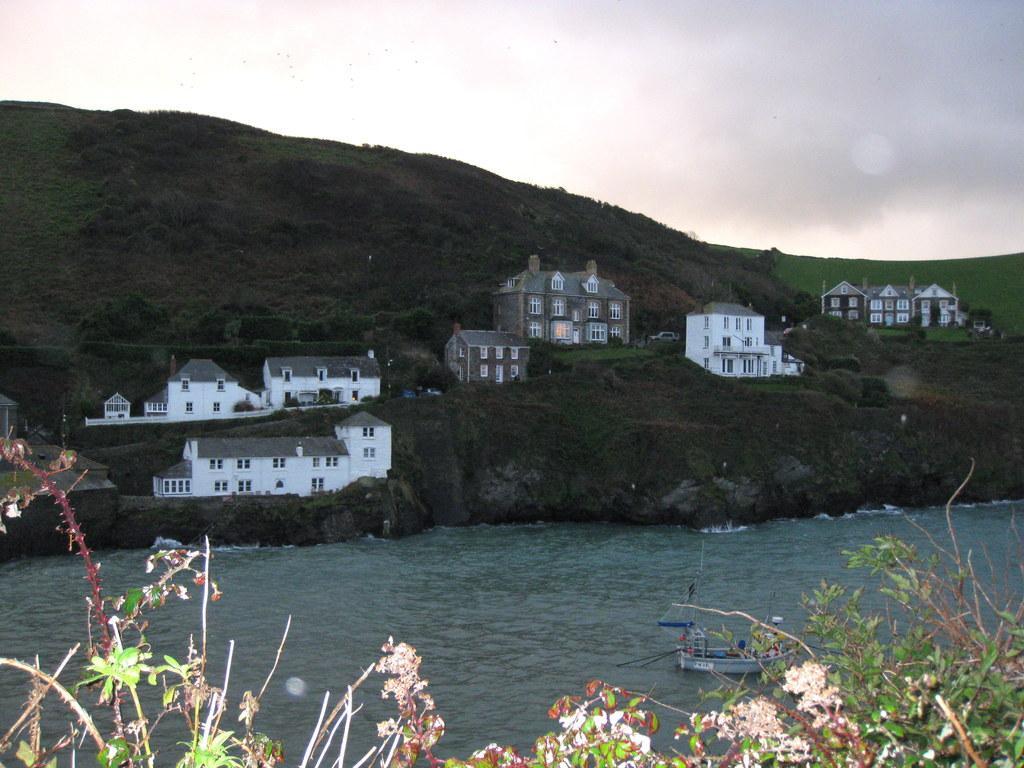Please provide a concise description of this image. In this image a boat is sailing on a river and there are plants , in the background there is mountain, on that mountain there are houses and there is a sky. 